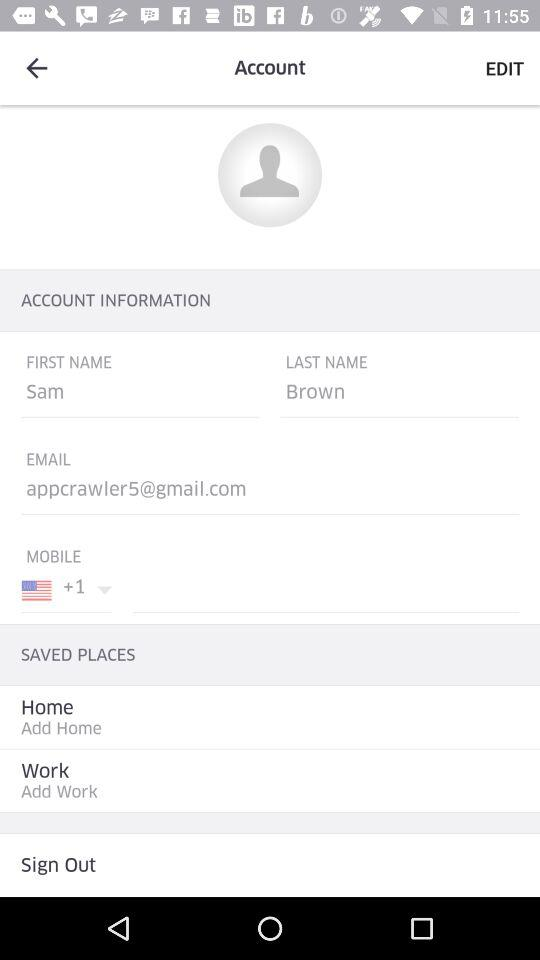What is the email address? The email address is appcrawler5@gmail.com. 